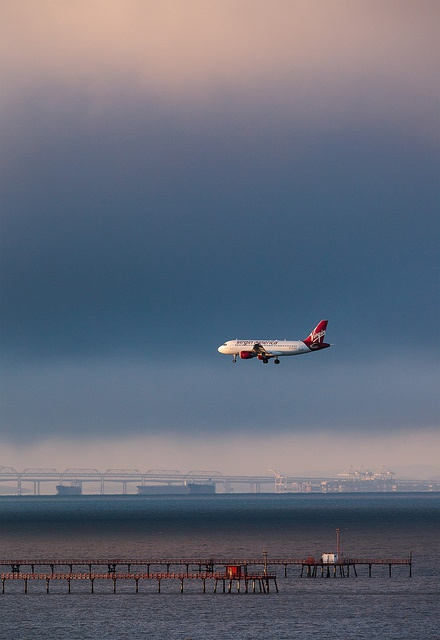Describe the objects in this image and their specific colors. I can see a airplane in tan, black, darkgray, and gray tones in this image. 